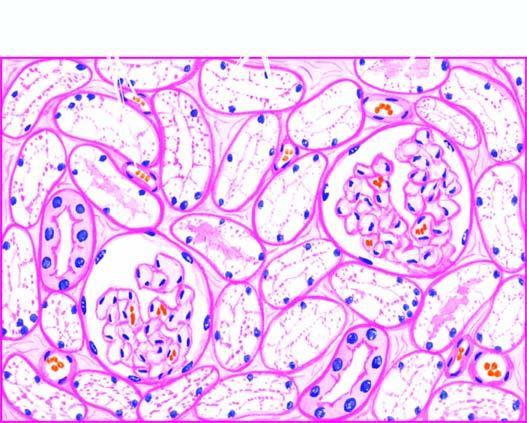what are the tubular epithelial cells distended with?
Answer the question using a single word or phrase. Cytoplasmic vacuoles 